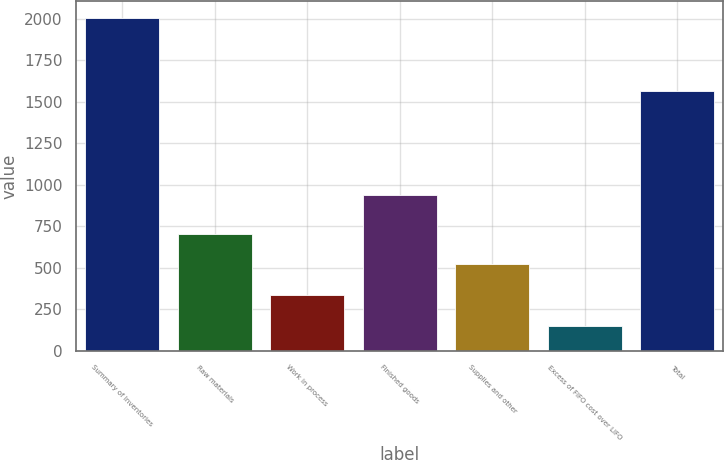Convert chart to OTSL. <chart><loc_0><loc_0><loc_500><loc_500><bar_chart><fcel>Summary of Inventories<fcel>Raw materials<fcel>Work in process<fcel>Finished goods<fcel>Supplies and other<fcel>Excess of FIFO cost over LIFO<fcel>Total<nl><fcel>2003<fcel>706.25<fcel>335.75<fcel>935.2<fcel>521<fcel>150.5<fcel>1563.4<nl></chart> 